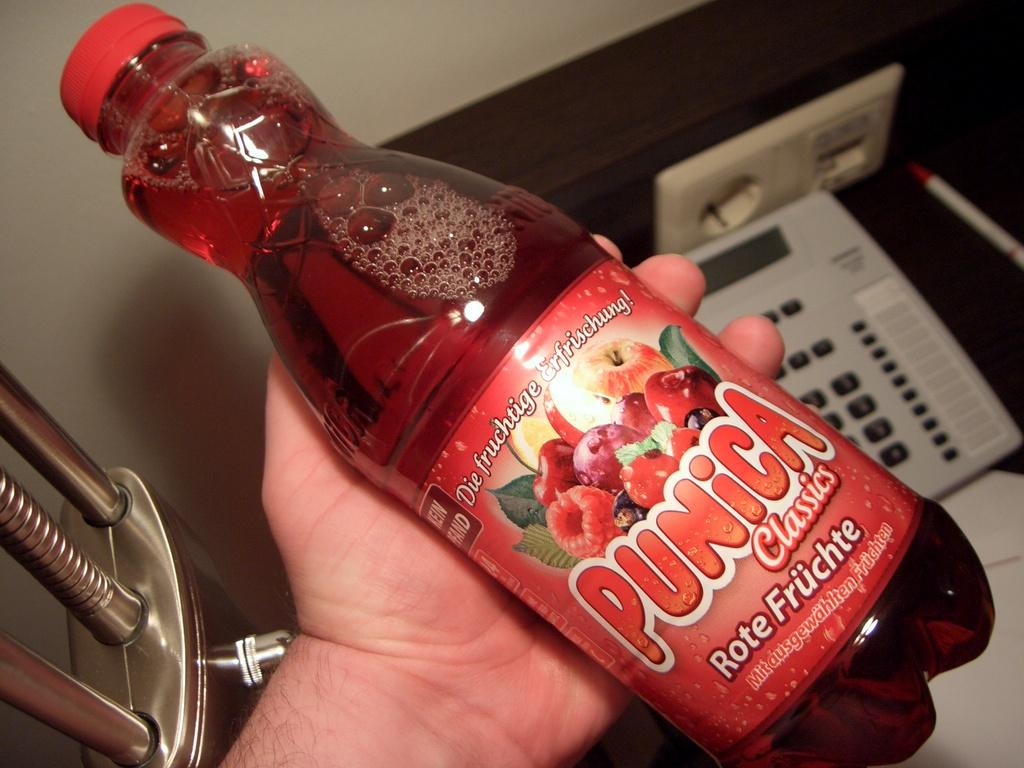<image>
Write a terse but informative summary of the picture. Someone is holding a bottle of red colored Punica in their hand. 